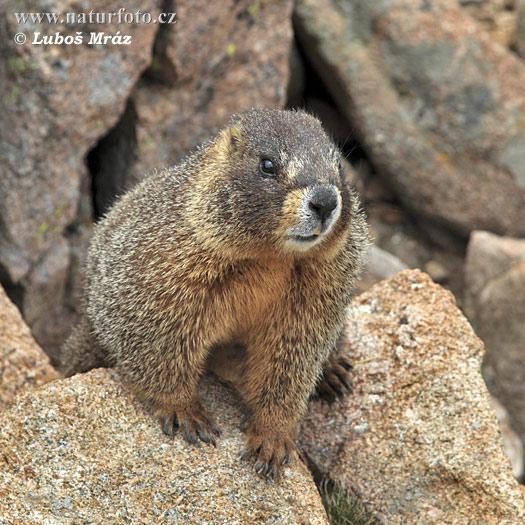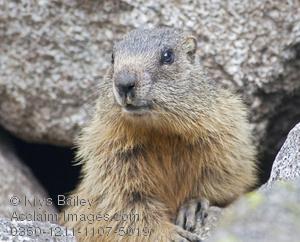The first image is the image on the left, the second image is the image on the right. For the images shown, is this caption "The animals in both images face approximately the same direction." true? Answer yes or no. No. 